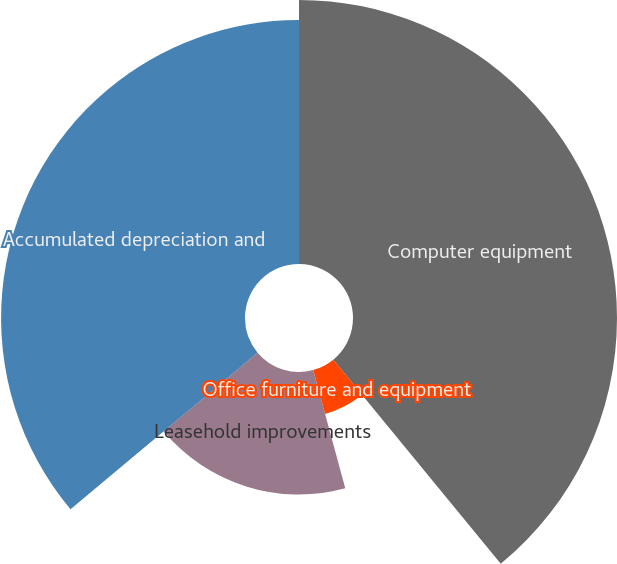Convert chart. <chart><loc_0><loc_0><loc_500><loc_500><pie_chart><fcel>Computer equipment<fcel>Office furniture and equipment<fcel>Leasehold improvements<fcel>Accumulated depreciation and<nl><fcel>39.06%<fcel>6.72%<fcel>18.13%<fcel>36.09%<nl></chart> 